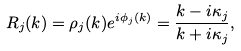Convert formula to latex. <formula><loc_0><loc_0><loc_500><loc_500>R _ { j } ( k ) = \rho _ { j } ( k ) e ^ { i \phi _ { j } ( k ) } = \frac { k - i \kappa _ { j } } { k + i \kappa _ { j } } ,</formula> 